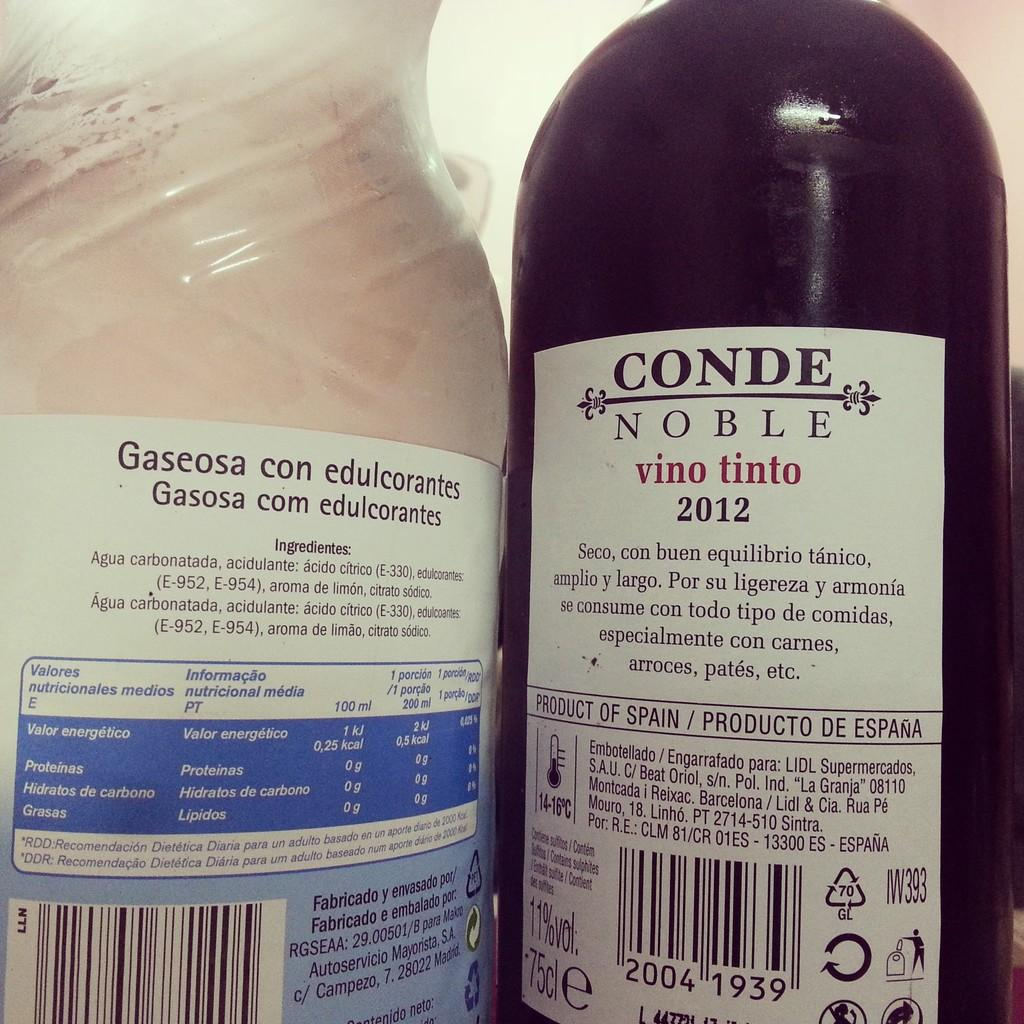<image>
Give a short and clear explanation of the subsequent image. the word conde is on the wine bottle 